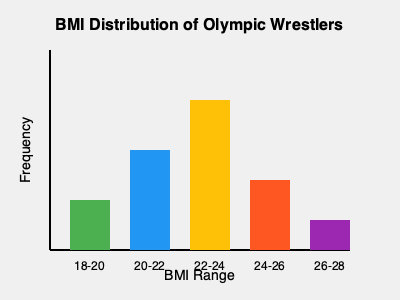Based on the BMI distribution graph of Olympic wrestlers, which BMI range appears to be the most common among the athletes, and what might this suggest about the optimal body composition for wrestling at the Olympic level? To answer this question, let's analyze the graph step-by-step:

1. The graph shows the BMI distribution of Olympic wrestlers across five ranges: 18-20, 20-22, 22-24, 24-26, and 26-28.

2. Each bar represents the frequency of wrestlers falling within that BMI range.

3. Comparing the heights of the bars:
   - The tallest bar corresponds to the 22-24 BMI range.
   - This indicates that the highest number of Olympic wrestlers fall within this BMI range.

4. The 22-24 BMI range being the most common suggests:
   - This may be an optimal range for combining strength, agility, and weight management in Olympic wrestling.
   - It balances muscle mass with body fat percentage, allowing for power and endurance.

5. The lower frequency in the 18-20 and 26-28 ranges implies:
   - Very low BMIs might not provide enough muscle mass and strength.
   - Very high BMIs might reduce agility and endurance.

6. The moderate frequencies in the 20-22 and 24-26 ranges suggest:
   - These are also common ranges, indicating some flexibility in optimal body composition.
   - Different weight classes and individual body types may account for this spread.

7. For Olympic-level wrestling:
   - A BMI of 22-24 seems to offer the best compromise between strength, speed, and weight control.
   - This range likely allows athletes to meet weight class requirements while maintaining optimal performance.
Answer: 22-24 BMI; optimal balance of strength, agility, and weight management for Olympic wrestling. 